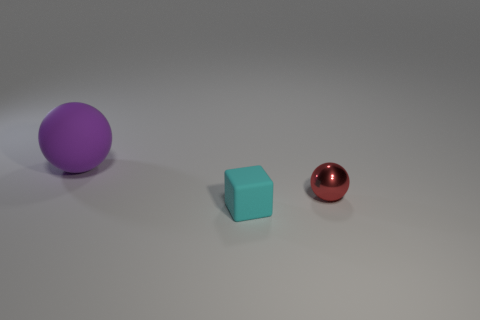Are there any other things that are made of the same material as the tiny red sphere?
Your answer should be compact. No. Does the tiny shiny sphere have the same color as the rubber thing to the right of the purple ball?
Ensure brevity in your answer.  No. There is a big purple object that is made of the same material as the cube; what is its shape?
Offer a very short reply. Sphere. There is a matte object in front of the purple rubber ball; does it have the same shape as the large purple object?
Give a very brief answer. No. There is a matte thing in front of the matte thing behind the cyan matte cube; what size is it?
Offer a terse response. Small. There is another thing that is the same material as the small cyan thing; what color is it?
Ensure brevity in your answer.  Purple. What number of balls have the same size as the cube?
Your answer should be very brief. 1. What number of cyan objects are either tiny cylinders or tiny matte objects?
Provide a short and direct response. 1. What number of objects are purple cylinders or objects left of the small metallic object?
Keep it short and to the point. 2. What is the material of the sphere in front of the big purple sphere?
Offer a terse response. Metal. 